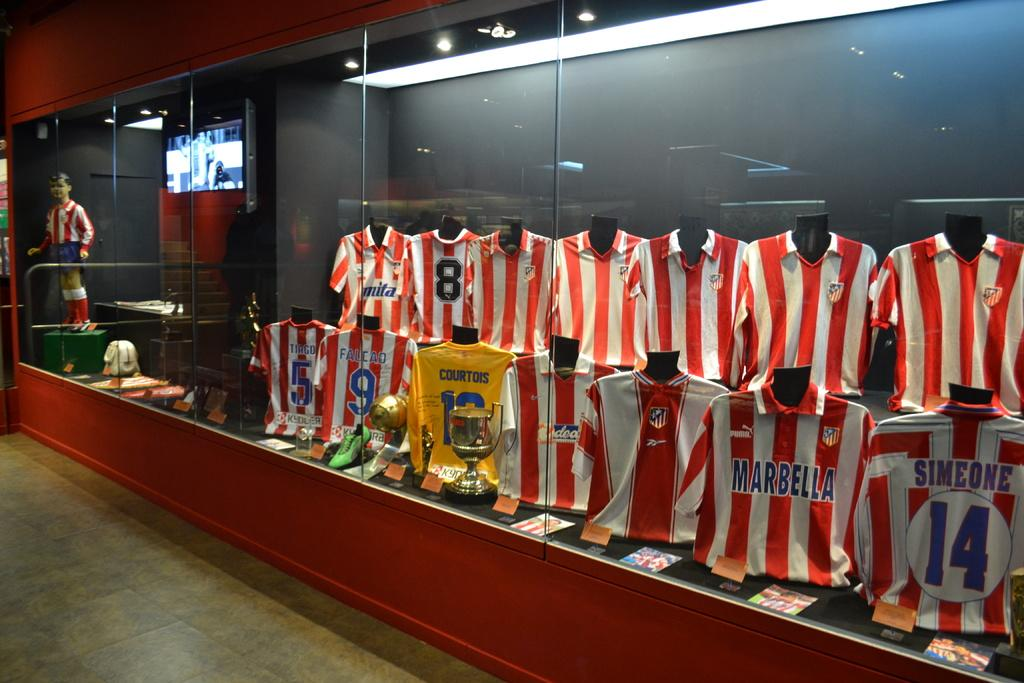<image>
Summarize the visual content of the image. The display of red and white striped jerseys includes Tiago's and Falcao's. 